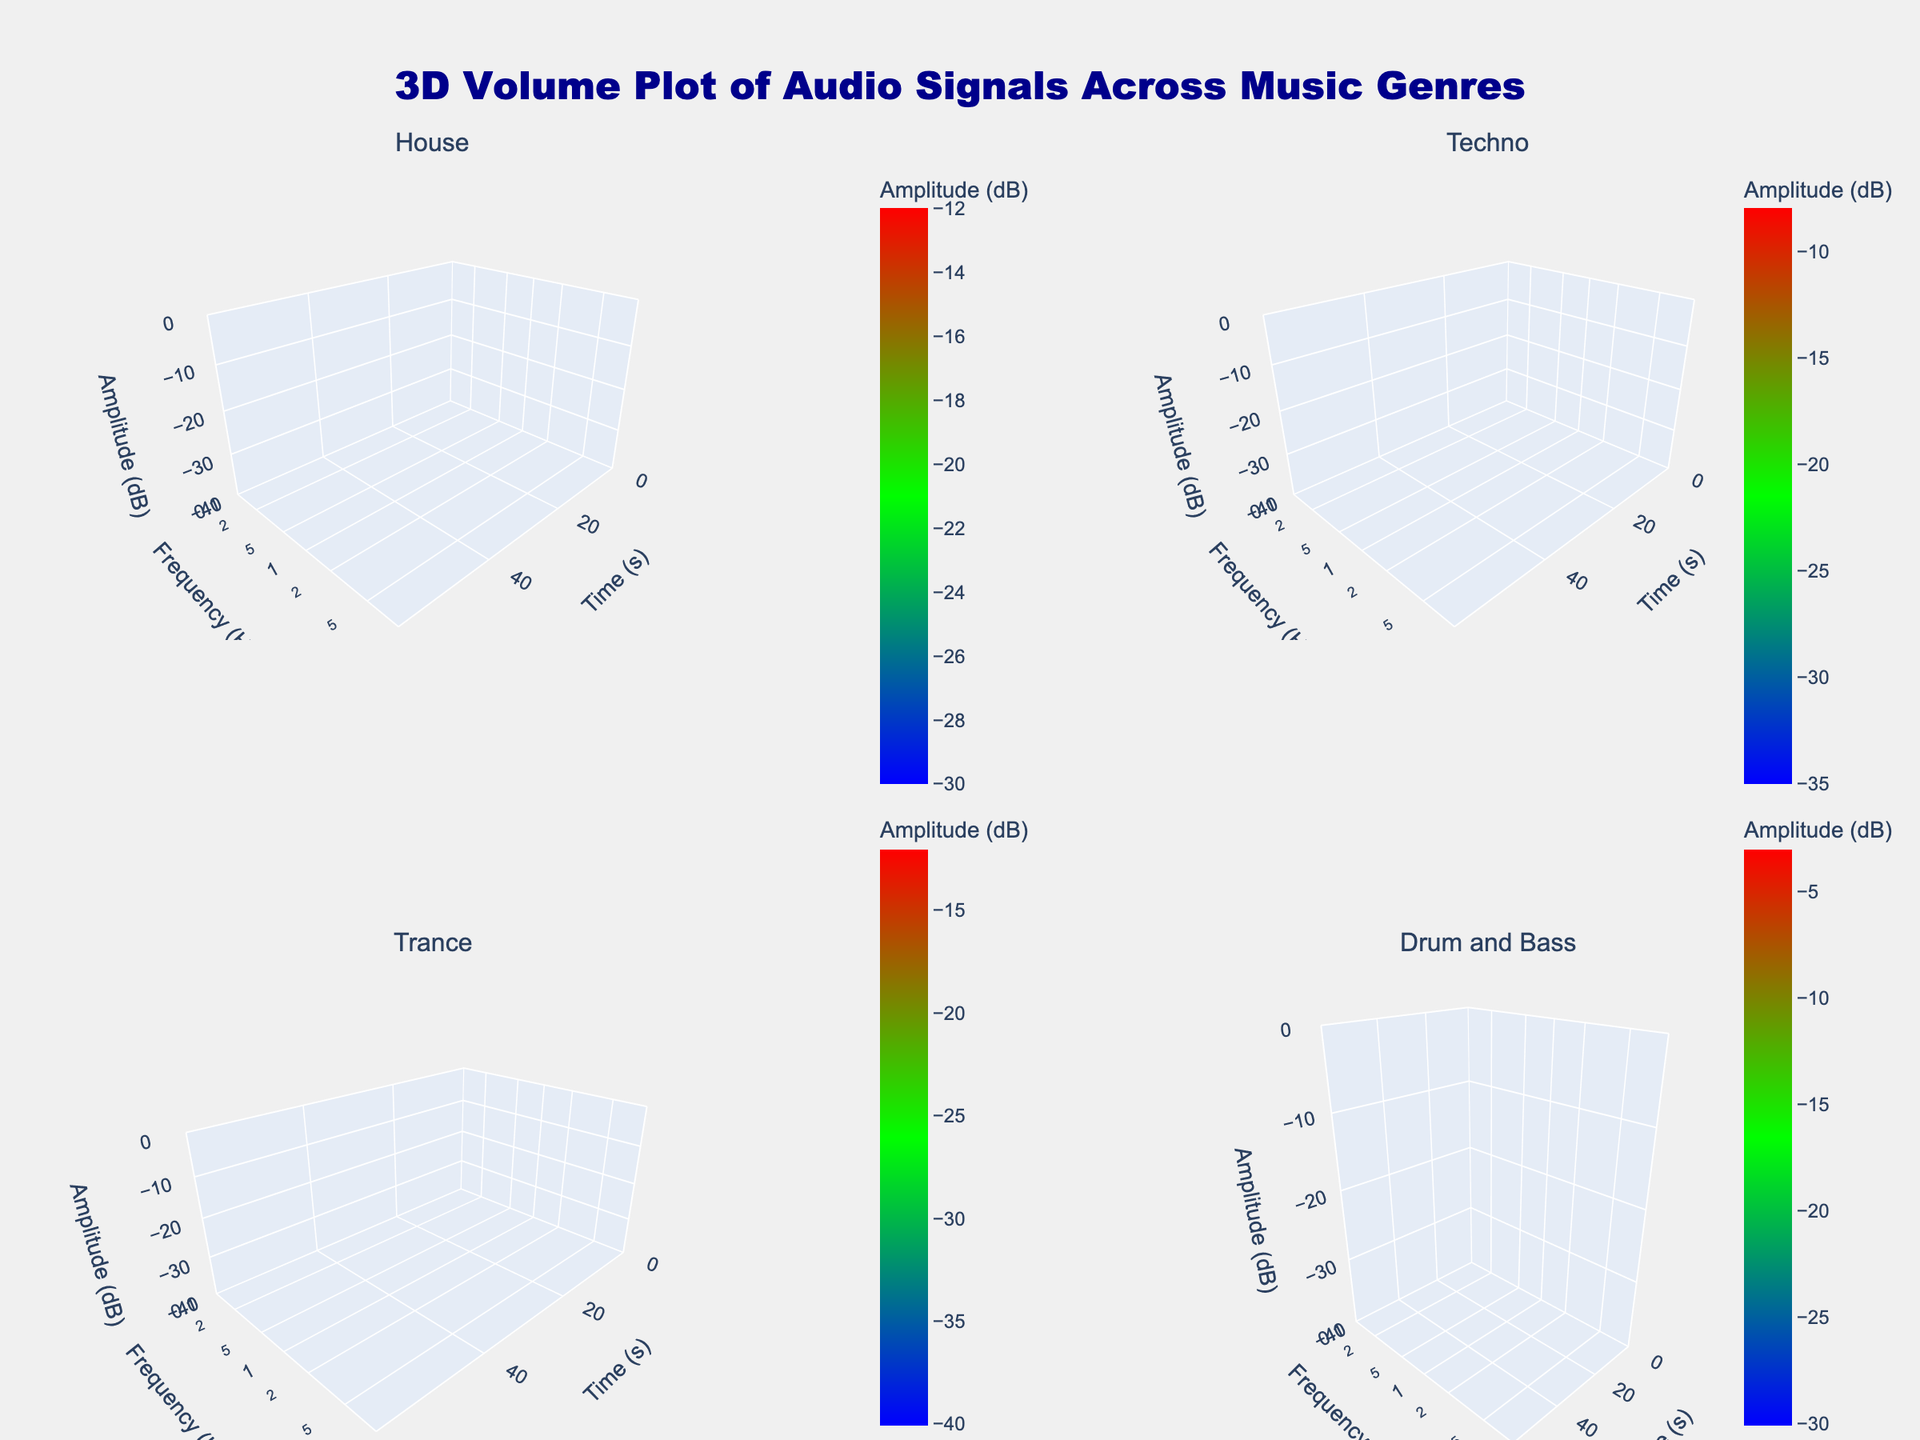What's the title of the plot? The title is usually located at the top of the plot and often provides a summary of what the plot is about. In this case, it reads "3D Volume Plot of Audio Signals Across Music Genres".
Answer: 3D Volume Plot of Audio Signals Across Music Genres Which axis represents the frequency? By looking at the axis labels, we can see that the y-axis title is "Frequency (Hz)", indicating that the y-axis represents the frequency.
Answer: y-axis What is the frequency range displayed for the 'Drum and Bass' genre? For the Drum and Bass genre, the frequency values range from 80 Hz to 8000 Hz.
Answer: 80 Hz to 8000 Hz Which genre shows the highest amplitude at time zero? By comparing the amplitude values at time zero for each genre, the Drum and Bass genre has the highest amplitude value of -5 dB.
Answer: Drum and Bass How does the amplitude for Techno at 50 Hz change over time? At time zero, the amplitude for Techno at 50 Hz is -25 dB. At 45 seconds, the amplitude increases to -22 dB, indicating a slight increase.
Answer: Increases Which genre has the lowest amplitude at high frequencies (10,000 Hz or more)? From the data and the plot, House and Trance genres exhibit high-frequency information. House shows -30 dB at 10,000 Hz, while Trance shows -40 dB at 20,000 Hz. Trance has the lowest amplitude.
Answer: Trance What is the color scale used to represent amplitude values? The color scale ranges from blue (low amplitude), transitioning through green, to red (high amplitude).
Answer: Blue to Red What is the overall trend of amplitude for the Trance genre as frequency increases at time zero? In the Trance subplot, the amplitude decreases as the frequency increases.
Answer: Decreases Compare the change in amplitude over time between House and Techno for their highest frequencies. Both House and Techno show a decrease in amplitude for their highest frequencies from -30 to -28 dB and -35 to -32 dB, respectively. The rate of decrease is similar for both genres.
Answer: Similar decrease Is the variation in the amplitude values for House more pronounced at lower or higher frequencies? For House, the variation in amplitude is more pronounced at lower frequencies (100 Hz and 1000 Hz) compared to the higher frequency (10000 Hz) which shows less variation.
Answer: Lower frequencies 